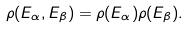<formula> <loc_0><loc_0><loc_500><loc_500>\rho ( E _ { \alpha } , E _ { \beta } ) = \rho ( E _ { \alpha } ) \rho ( E _ { \beta } ) .</formula> 